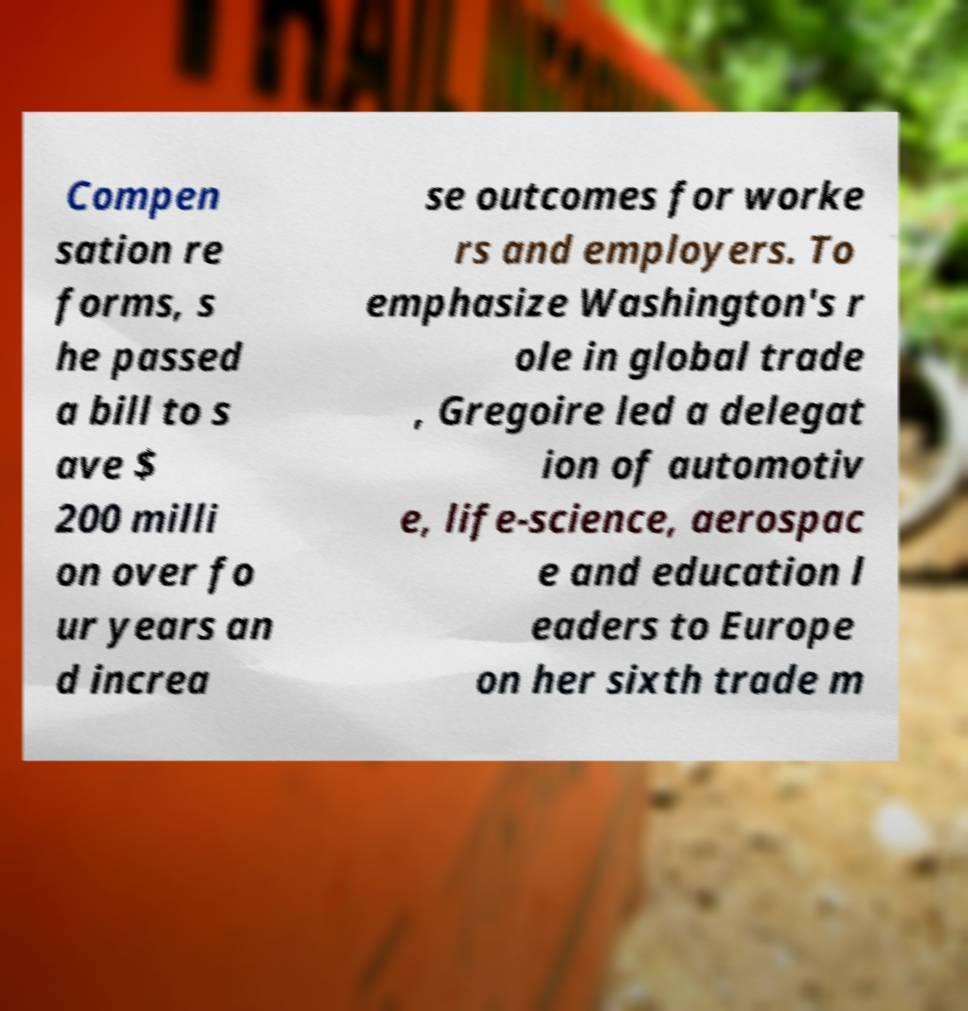Could you assist in decoding the text presented in this image and type it out clearly? Compen sation re forms, s he passed a bill to s ave $ 200 milli on over fo ur years an d increa se outcomes for worke rs and employers. To emphasize Washington's r ole in global trade , Gregoire led a delegat ion of automotiv e, life-science, aerospac e and education l eaders to Europe on her sixth trade m 